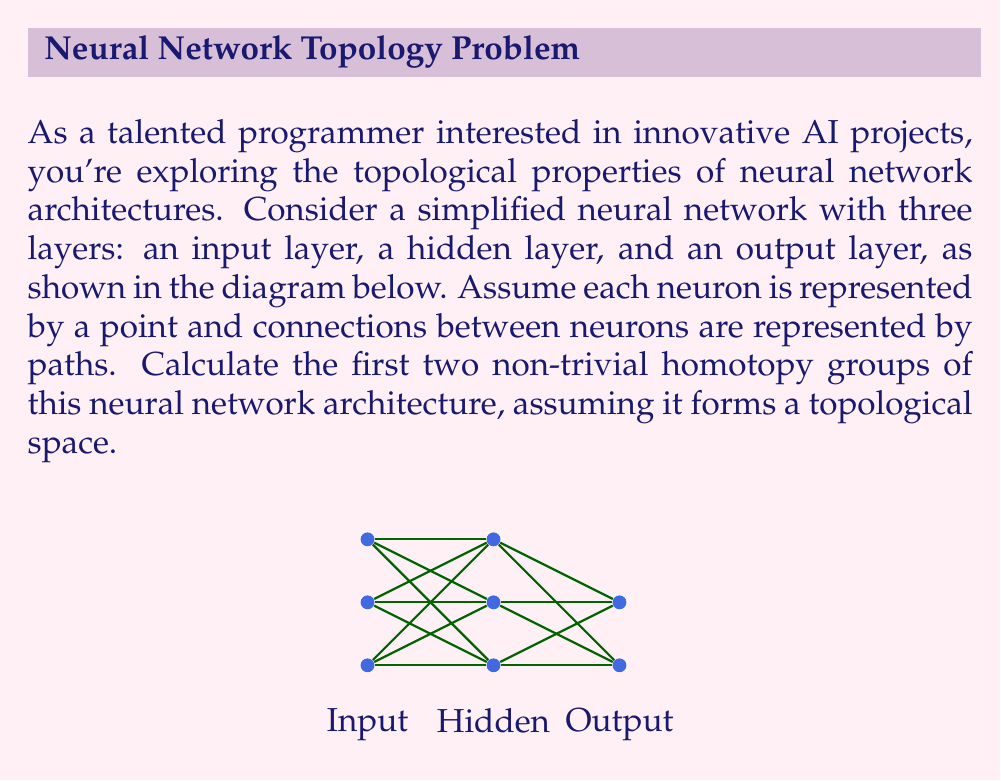Teach me how to tackle this problem. To calculate the homotopy groups of this neural network architecture, we need to analyze its topological structure:

1. First, observe that the network forms a graph-like structure with nodes (neurons) and edges (connections).

2. Topologically, this structure is homotopy equivalent to a wedge sum of circles. Each cycle in the graph corresponds to a circle in the wedge sum.

3. To count the number of independent cycles, we can use the formula:
   $$ \text{Number of cycles} = E - V + 1 $$
   where $E$ is the number of edges and $V$ is the number of vertices.

4. In this network:
   - Input layer: 3 neurons
   - Hidden layer: 3 neurons
   - Output layer: 2 neurons
   Total vertices: $V = 3 + 3 + 2 = 8$

   Edges: $(3 \times 3) + (3 \times 2) = 15$

5. Number of cycles = $15 - 8 + 1 = 8$

6. The homotopy groups of a wedge sum of $n$ circles are:

   $\pi_1(X) \cong \mathbb{Z} * \mathbb{Z} * ... * \mathbb{Z}$ ($n$ times)
   $\pi_k(X) \cong 0$ for $k \geq 2$

7. Therefore, the first non-trivial homotopy group $\pi_1$ is isomorphic to the free group on 8 generators.

8. All higher homotopy groups are trivial.
Answer: $\pi_1 \cong \mathbb{Z} * \mathbb{Z} * \mathbb{Z} * \mathbb{Z} * \mathbb{Z} * \mathbb{Z} * \mathbb{Z} * \mathbb{Z}$, $\pi_k \cong 0$ for $k \geq 2$ 